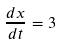Convert formula to latex. <formula><loc_0><loc_0><loc_500><loc_500>\frac { d x } { d t } = 3</formula> 